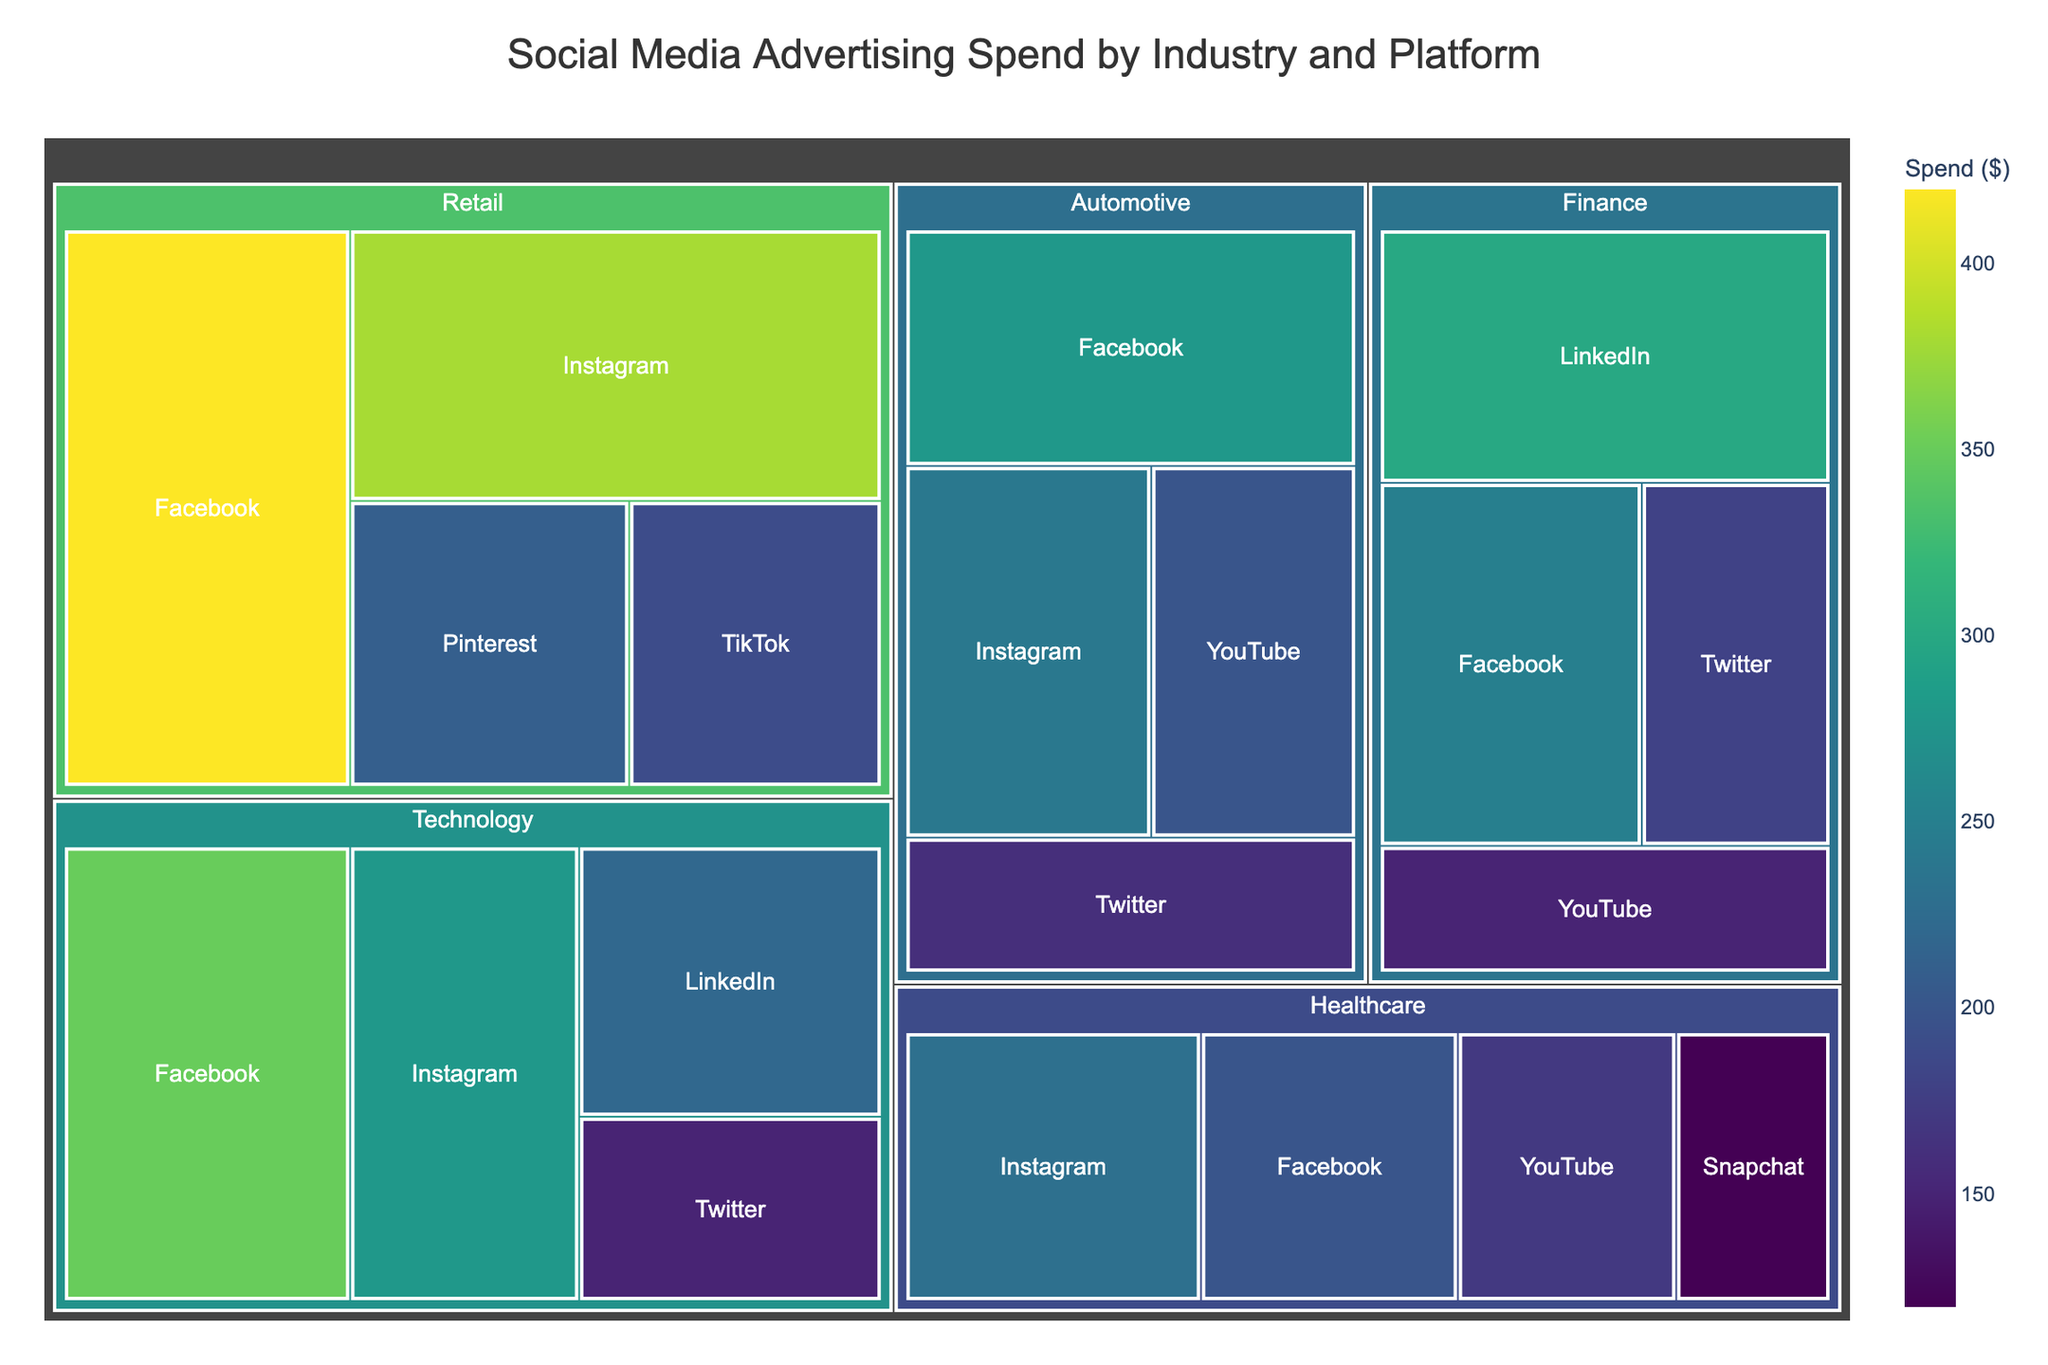What is the title of the Treemap? The title of the treemap is displayed prominently at the top of the figure. By glancing at the top, one can read it directly.
Answer: Social Media Advertising Spend by Industry and Platform Which platform has the highest advertising spend in the Retail industry? Look at the sections under the Retail industry. Each platform is color-coded with the spend amount shown. The platform with the largest box or highest numerical value is the answer.
Answer: Facebook Which industry spends the most on Instagram? Search for Instagram within each industry. Compare the spending values, identify the highest value.
Answer: Retail What is the total advertising spend for the Technology industry across all platforms? Sum up the spend values for all platforms under the Technology industry: (350 + 280 + 220 + 150)
Answer: 1000 Which industry has the smallest spend on YouTube? Look at all YouTube spends across industries. The smallest box or lowest numerical value is the answer.
Answer: Healthcare What is the difference in advertising spend between Facebook and Twitter in the Automotive industry? Identify the spend amounts for Facebook and Twitter within the Automotive industry. Subtract the smaller value from the larger one: 280 - 160
Answer: 120 Among all platforms, which one has the highest combined advertising spend across all industries? Sum the spend values for each platform across all industries. The highest resulting sum is the answer. For example, sum all Facebook spends, all Instagram spends, etc., and then compare.
Answer: Facebook Which platform has the smallest advertising spend within the Healthcare industry? Examine the spend values for all platforms within Healthcare. The smallest amount is the answer.
Answer: Snapchat How does the advertising spend on LinkedIn compare between the Technology and Finance industries? Find the spend values for LinkedIn in both Technology and Finance industries. Then compare the two values directly: 220 (Technology) and 300 (Finance).
Answer: Finance spends more What's the total advertising spend for all platforms in the specified data? Sum up all the individual spend values listed in the dataset: (350 + 280 + 220 + 150 + 420 + 380 + 210 + 190 + 300 + 250 + 180 + 150 + 230 + 200 + 170 + 120 + 280 + 240 + 200 + 160)
Answer: 4600 